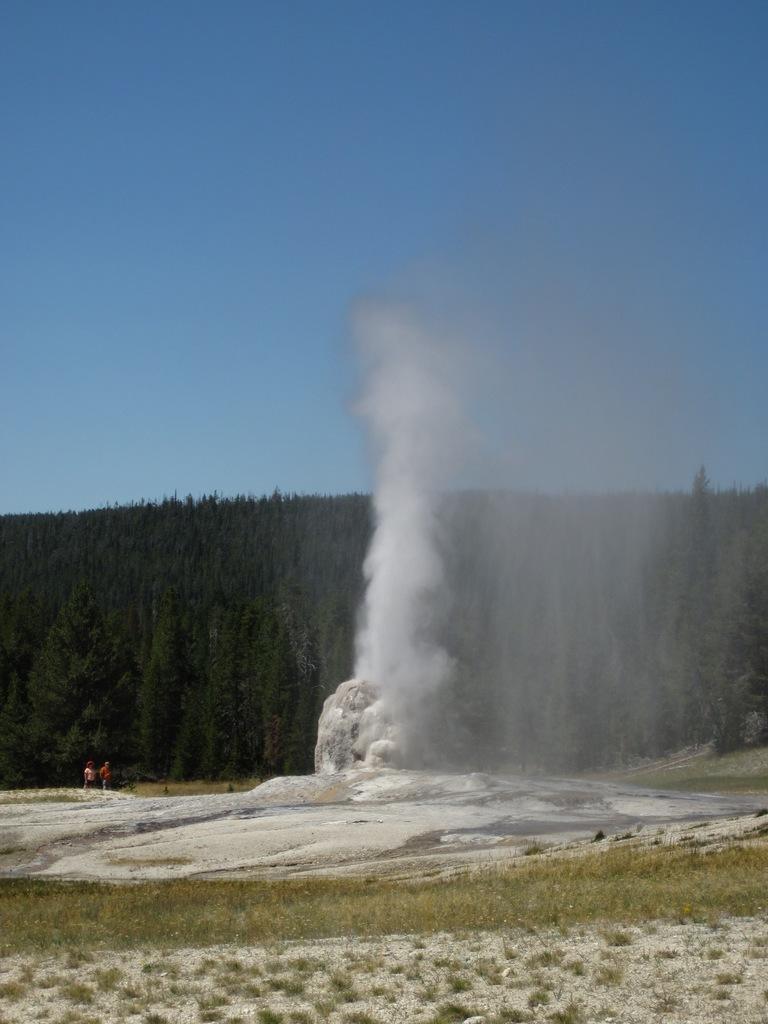Could you give a brief overview of what you see in this image? In this image I can see grass, ice, two persons and smoke. In the background I can see trees, mountains and the sky. This image is taken may be near the mountains. 